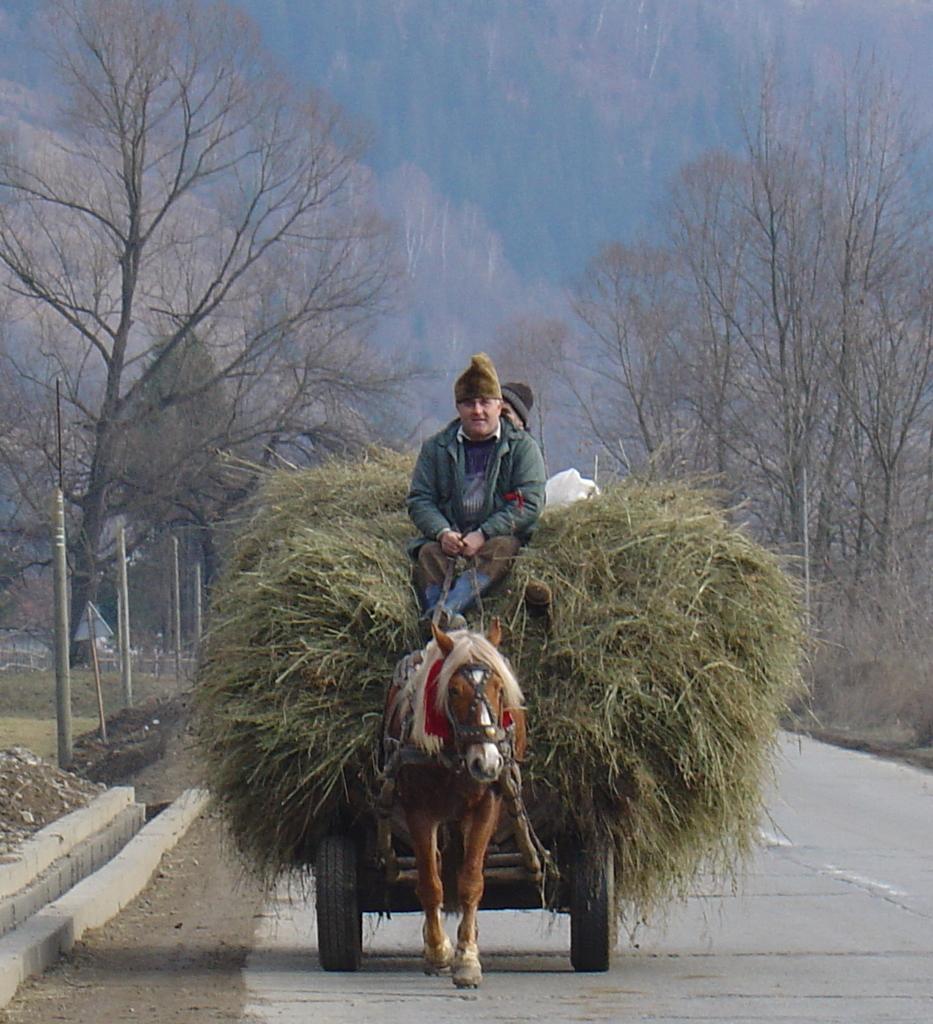Please provide a concise description of this image. In this image I can see the road, an animal cart on the road. On the animal cart I can see huge grass bundle and a person sitting on it. In the background I can see few poles, few trees and the sky. 